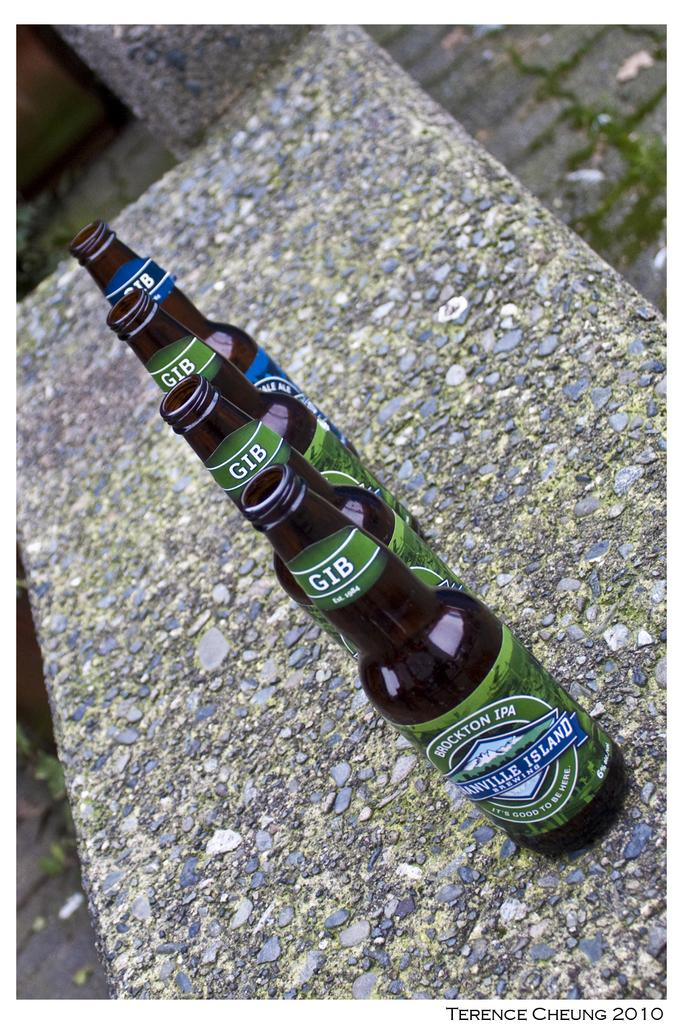<image>
Write a terse but informative summary of the picture. 4 Granville Island beer bottles in a line outside. 